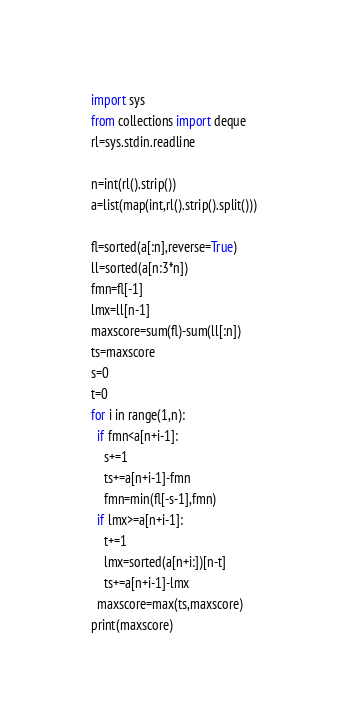Convert code to text. <code><loc_0><loc_0><loc_500><loc_500><_Python_>import sys
from collections import deque
rl=sys.stdin.readline

n=int(rl().strip())
a=list(map(int,rl().strip().split()))

fl=sorted(a[:n],reverse=True)
ll=sorted(a[n:3*n])
fmn=fl[-1]
lmx=ll[n-1]
maxscore=sum(fl)-sum(ll[:n])
ts=maxscore
s=0
t=0
for i in range(1,n):
  if fmn<a[n+i-1]:
    s+=1
    ts+=a[n+i-1]-fmn
    fmn=min(fl[-s-1],fmn)
  if lmx>=a[n+i-1]:
    t+=1
    lmx=sorted(a[n+i:])[n-t]
    ts+=a[n+i-1]-lmx
  maxscore=max(ts,maxscore)
print(maxscore)</code> 